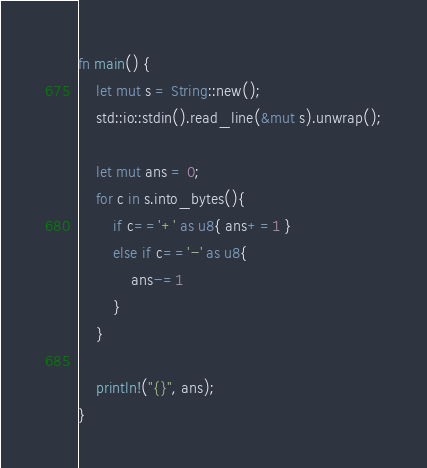Convert code to text. <code><loc_0><loc_0><loc_500><loc_500><_Rust_>fn main() {
    let mut s = String::new();
    std::io::stdin().read_line(&mut s).unwrap();

    let mut ans = 0;
    for c in s.into_bytes(){
        if c=='+' as u8{ ans+=1 }
        else if c=='-' as u8{
            ans-=1
        }
    }

    println!("{}", ans);
}
</code> 